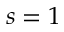<formula> <loc_0><loc_0><loc_500><loc_500>s = 1</formula> 